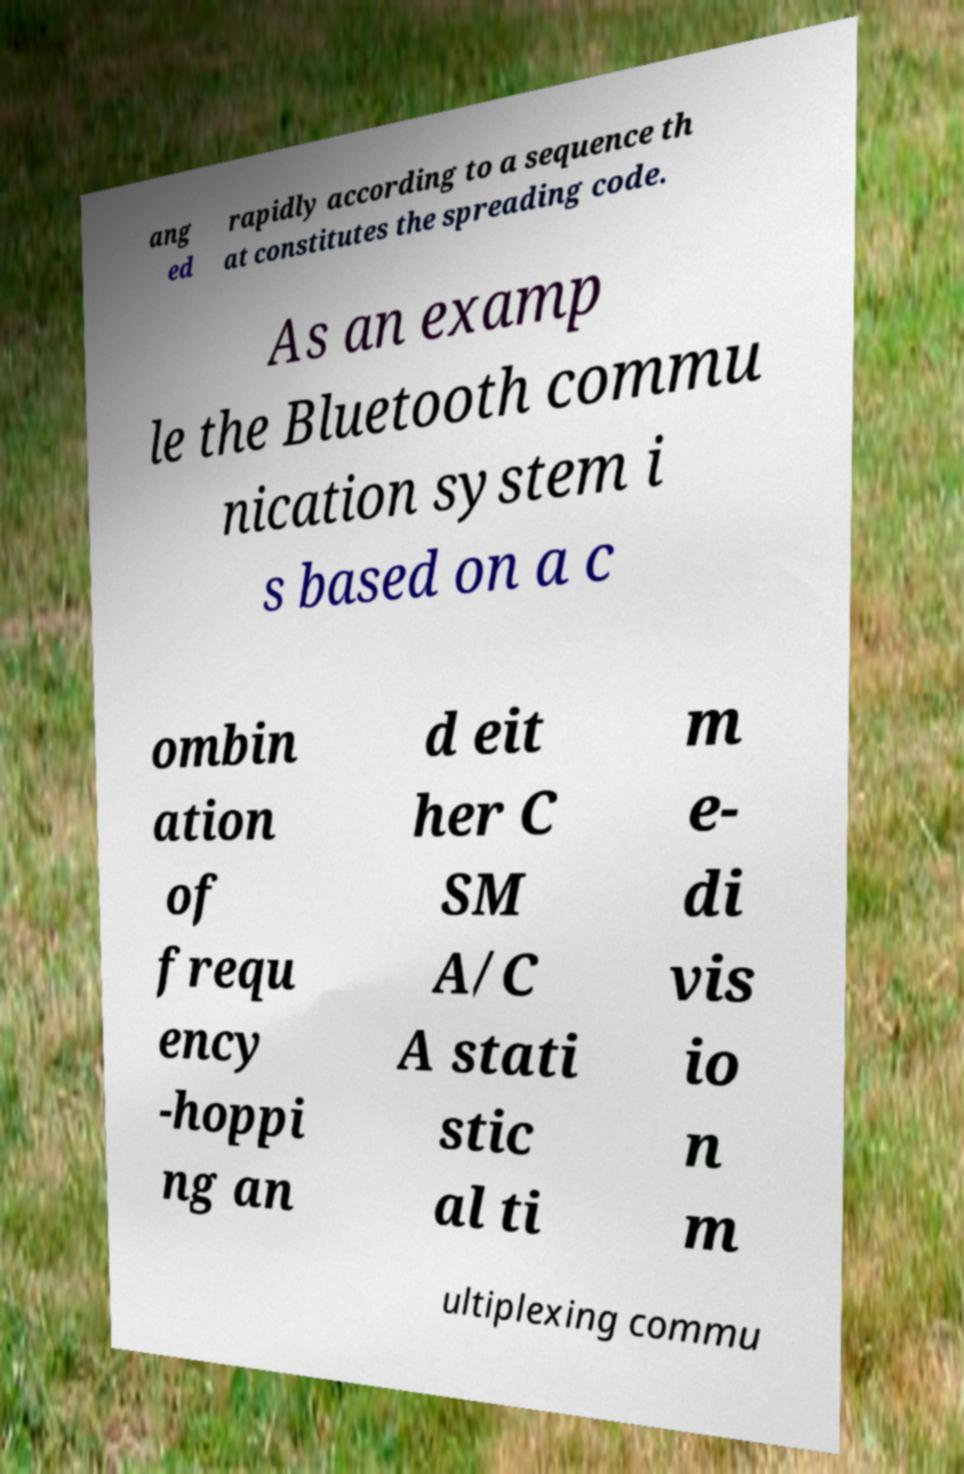Please read and relay the text visible in this image. What does it say? ang ed rapidly according to a sequence th at constitutes the spreading code. As an examp le the Bluetooth commu nication system i s based on a c ombin ation of frequ ency -hoppi ng an d eit her C SM A/C A stati stic al ti m e- di vis io n m ultiplexing commu 